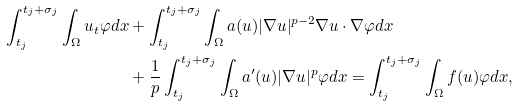<formula> <loc_0><loc_0><loc_500><loc_500>\int _ { t _ { j } } ^ { t _ { j } + \sigma _ { j } } \int _ { \Omega } u _ { t } \varphi d x & + \int _ { t _ { j } } ^ { t _ { j } + \sigma _ { j } } \int _ { \Omega } a ( u ) | \nabla u | ^ { p - 2 } \nabla u \cdot \nabla \varphi d x \\ & + \frac { 1 } { p } \int _ { t _ { j } } ^ { t _ { j } + \sigma _ { j } } \int _ { \Omega } a ^ { \prime } ( u ) | \nabla u | ^ { p } \varphi d x = \int _ { t _ { j } } ^ { t _ { j } + \sigma _ { j } } \int _ { \Omega } f ( u ) \varphi d x ,</formula> 